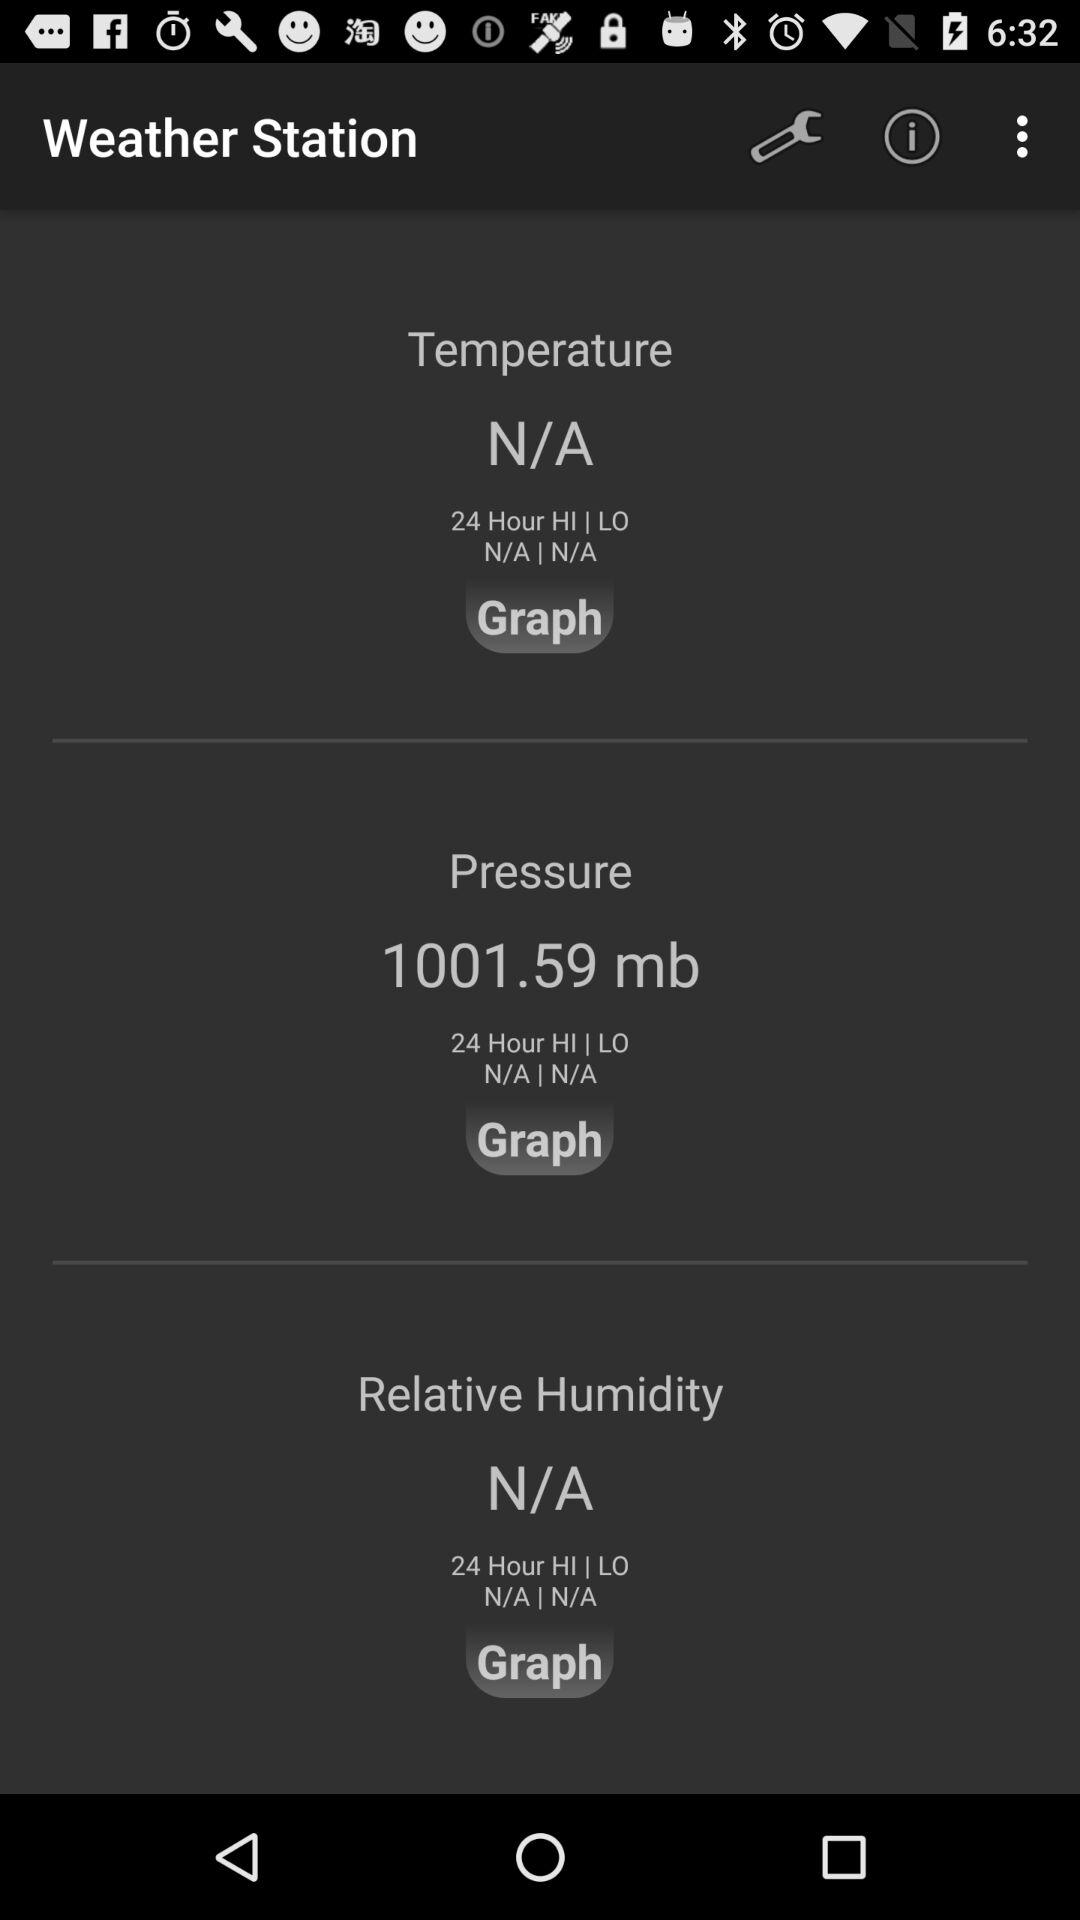What is the air pressure? The air pressure is 1001.59 millibars. 